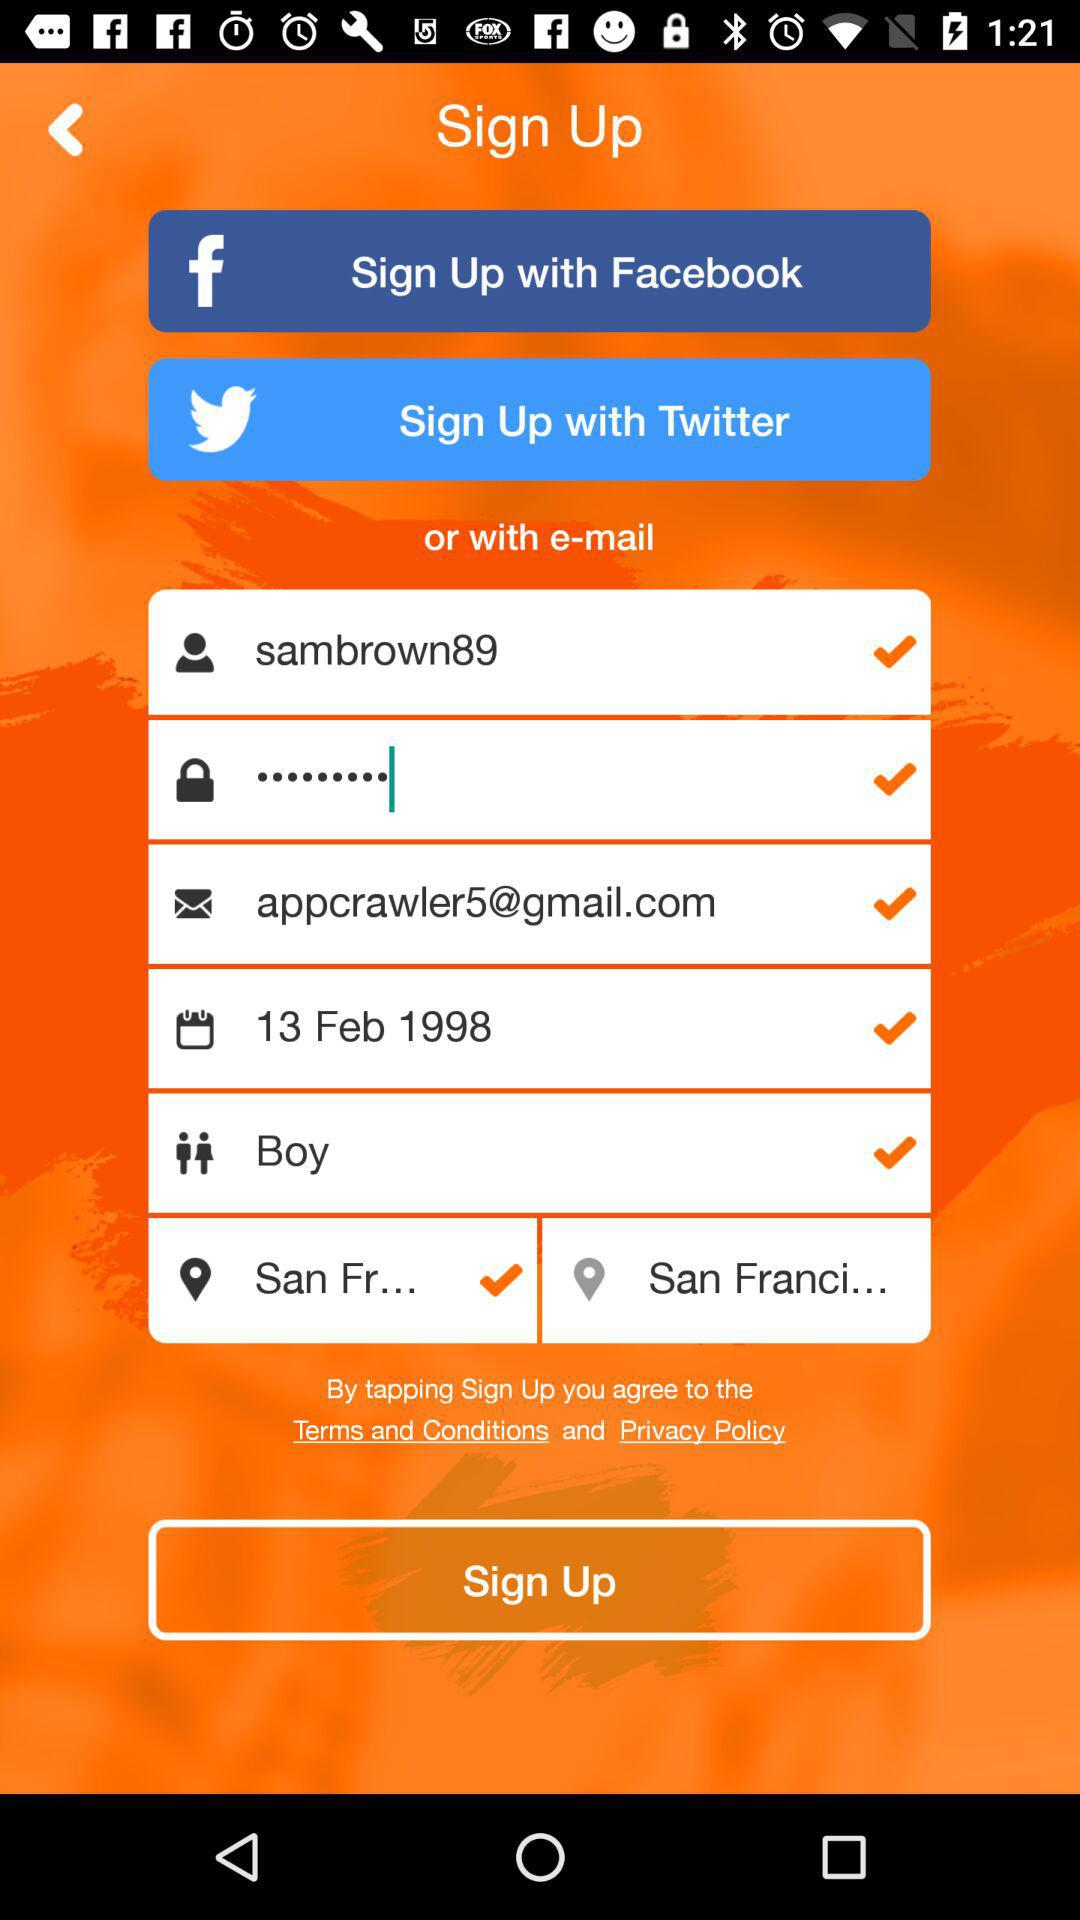What are the options for signing up? The options for signing up are "Facebook", "Twitter" and "e-mail". 